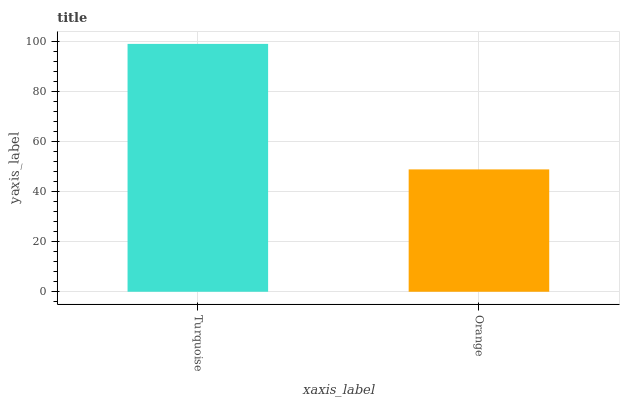Is Orange the minimum?
Answer yes or no. Yes. Is Turquoise the maximum?
Answer yes or no. Yes. Is Orange the maximum?
Answer yes or no. No. Is Turquoise greater than Orange?
Answer yes or no. Yes. Is Orange less than Turquoise?
Answer yes or no. Yes. Is Orange greater than Turquoise?
Answer yes or no. No. Is Turquoise less than Orange?
Answer yes or no. No. Is Turquoise the high median?
Answer yes or no. Yes. Is Orange the low median?
Answer yes or no. Yes. Is Orange the high median?
Answer yes or no. No. Is Turquoise the low median?
Answer yes or no. No. 